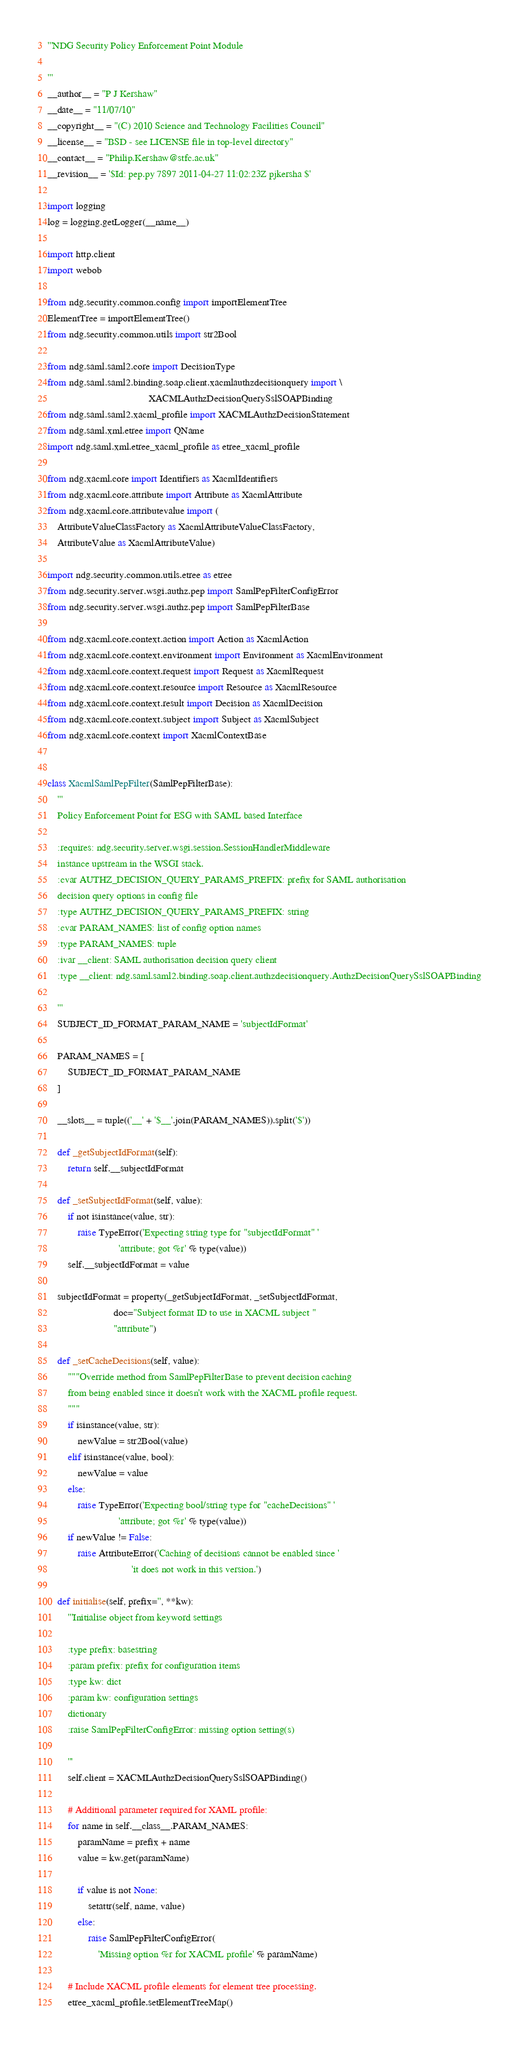Convert code to text. <code><loc_0><loc_0><loc_500><loc_500><_Python_>'''NDG Security Policy Enforcement Point Module

'''
__author__ = "P J Kershaw"
__date__ = "11/07/10"
__copyright__ = "(C) 2010 Science and Technology Facilities Council"
__license__ = "BSD - see LICENSE file in top-level directory"
__contact__ = "Philip.Kershaw@stfc.ac.uk"
__revision__ = '$Id: pep.py 7897 2011-04-27 11:02:23Z pjkersha $'

import logging
log = logging.getLogger(__name__)

import http.client
import webob

from ndg.security.common.config import importElementTree
ElementTree = importElementTree()
from ndg.security.common.utils import str2Bool

from ndg.saml.saml2.core import DecisionType
from ndg.saml.saml2.binding.soap.client.xacmlauthzdecisionquery import \
                                        XACMLAuthzDecisionQuerySslSOAPBinding
from ndg.saml.saml2.xacml_profile import XACMLAuthzDecisionStatement
from ndg.saml.xml.etree import QName
import ndg.saml.xml.etree_xacml_profile as etree_xacml_profile

from ndg.xacml.core import Identifiers as XacmlIdentifiers
from ndg.xacml.core.attribute import Attribute as XacmlAttribute
from ndg.xacml.core.attributevalue import (
    AttributeValueClassFactory as XacmlAttributeValueClassFactory, 
    AttributeValue as XacmlAttributeValue)
    
import ndg.security.common.utils.etree as etree
from ndg.security.server.wsgi.authz.pep import SamlPepFilterConfigError
from ndg.security.server.wsgi.authz.pep import SamlPepFilterBase

from ndg.xacml.core.context.action import Action as XacmlAction
from ndg.xacml.core.context.environment import Environment as XacmlEnvironment
from ndg.xacml.core.context.request import Request as XacmlRequest
from ndg.xacml.core.context.resource import Resource as XacmlResource
from ndg.xacml.core.context.result import Decision as XacmlDecision
from ndg.xacml.core.context.subject import Subject as XacmlSubject
from ndg.xacml.core.context import XacmlContextBase


class XacmlSamlPepFilter(SamlPepFilterBase):
    '''
    Policy Enforcement Point for ESG with SAML based Interface
    
    :requires: ndg.security.server.wsgi.session.SessionHandlerMiddleware 
    instance upstream in the WSGI stack.
    :cvar AUTHZ_DECISION_QUERY_PARAMS_PREFIX: prefix for SAML authorisation
    decision query options in config file
    :type AUTHZ_DECISION_QUERY_PARAMS_PREFIX: string  
    :cvar PARAM_NAMES: list of config option names
    :type PARAM_NAMES: tuple
    :ivar __client: SAML authorisation decision query client 
    :type __client: ndg.saml.saml2.binding.soap.client.authzdecisionquery.AuthzDecisionQuerySslSOAPBinding

    '''
    SUBJECT_ID_FORMAT_PARAM_NAME = 'subjectIdFormat'

    PARAM_NAMES = [
        SUBJECT_ID_FORMAT_PARAM_NAME
    ]

    __slots__ = tuple(('__' + '$__'.join(PARAM_NAMES)).split('$'))

    def _getSubjectIdFormat(self):
        return self.__subjectIdFormat

    def _setSubjectIdFormat(self, value):
        if not isinstance(value, str):
            raise TypeError('Expecting string type for "subjectIdFormat" '
                            'attribute; got %r' % type(value))
        self.__subjectIdFormat = value

    subjectIdFormat = property(_getSubjectIdFormat, _setSubjectIdFormat, 
                          doc="Subject format ID to use in XACML subject "
                          "attribute")

    def _setCacheDecisions(self, value):
        """Override method from SamlPepFilterBase to prevent decision caching
        from being enabled since it doesn't work with the XACML profile request.
        """
        if isinstance(value, str):
            newValue = str2Bool(value)
        elif isinstance(value, bool):
            newValue = value
        else:
            raise TypeError('Expecting bool/string type for "cacheDecisions" '
                            'attribute; got %r' % type(value))
        if newValue != False:
            raise AttributeError('Caching of decisions cannot be enabled since '
                                 'it does not work in this version.')

    def initialise(self, prefix='', **kw):
        '''Initialise object from keyword settings
        
        :type prefix: basestring
        :param prefix: prefix for configuration items
        :type kw: dict        
        :param kw: configuration settings
        dictionary
        :raise SamlPepFilterConfigError: missing option setting(s)

        '''
        self.client = XACMLAuthzDecisionQuerySslSOAPBinding()
        
        # Additional parameter required for XAML profile:
        for name in self.__class__.PARAM_NAMES:
            paramName = prefix + name
            value = kw.get(paramName)
            
            if value is not None:
                setattr(self, name, value)
            else:
                raise SamlPepFilterConfigError(
                    'Missing option %r for XACML profile' % paramName)

        # Include XACML profile elements for element tree processing.
        etree_xacml_profile.setElementTreeMap()
</code> 